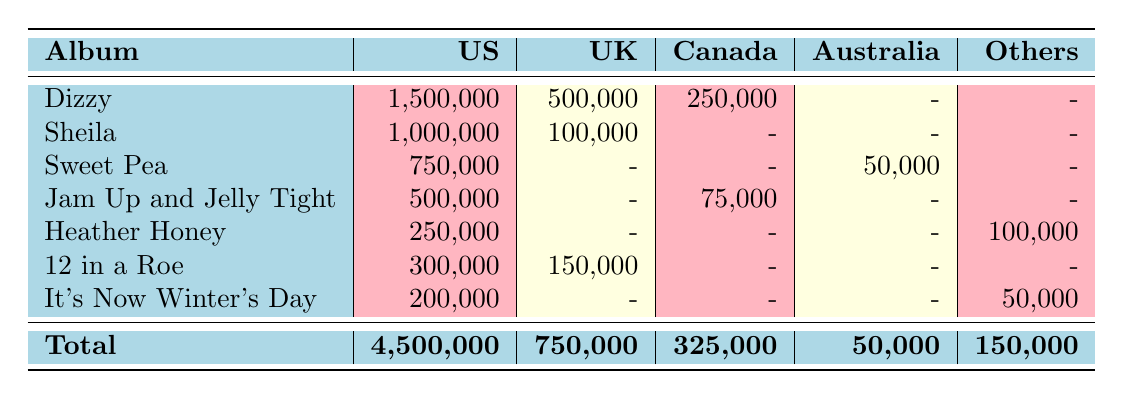What are the total sales figures for Tommy Roe's albums in the United States? To find the total sales in the US, I need to sum the sales of all albums listed under the "US" column. The sales figures are: 1,500,000 + 1,000,000 + 750,000 + 500,000 + 250,000 + 300,000 + 200,000 = 4,500,000.
Answer: 4,500,000 Which album had the highest sales in the United Kingdom? By looking at the "UK" column, the sales figures are: 500,000 (Dizzy), 100,000 (Sheila), 150,000 (12 in a Roe). The highest figure is 500,000 from "Dizzy".
Answer: Dizzy Did "Heather Honey" achieve Gold certification in the United States? "Heather Honey" has 250,000 sales in the US, but there is no mention of any certification in the table for this album. Hence, it did not achieve Gold certification.
Answer: No What is the combined total sales for the albums in Canada? To find the total sales in Canada, I will sum the sales figures listed in the "Canada" column: 250,000 (Dizzy) + 75,000 (Jam Up and Jelly Tight) = 325,000.
Answer: 325,000 Is the certification for "Sweet Pea" in Australia Gold? The table shows that "Sweet Pea" in Australia has 50,000 sales, and the certification is recorded as Gold. Therefore, the certification is indeed Gold.
Answer: Yes What is the difference in sales between "Dizzy" and "Sheila" in the United States? The sales figures in the US are: "Dizzy" has 1,500,000 and "Sheila" has 1,000,000. The difference is calculated as 1,500,000 - 1,000,000 = 500,000.
Answer: 500,000 Which album had sales in Germany and what were the figures? "Heather Honey" is the album listed with sales in Germany, showing 100,000 in the corresponding column.
Answer: Heather Honey, 100,000 What percentage of total US sales do the sales for "Jam Up and Jelly Tight" represent? First, the sales for "Jam Up and Jelly Tight" in the US is 500,000. Total US sales are 4,500,000. The percentage is calculated as (500,000 / 4,500,000) * 100 = 11.11%.
Answer: 11.11% 